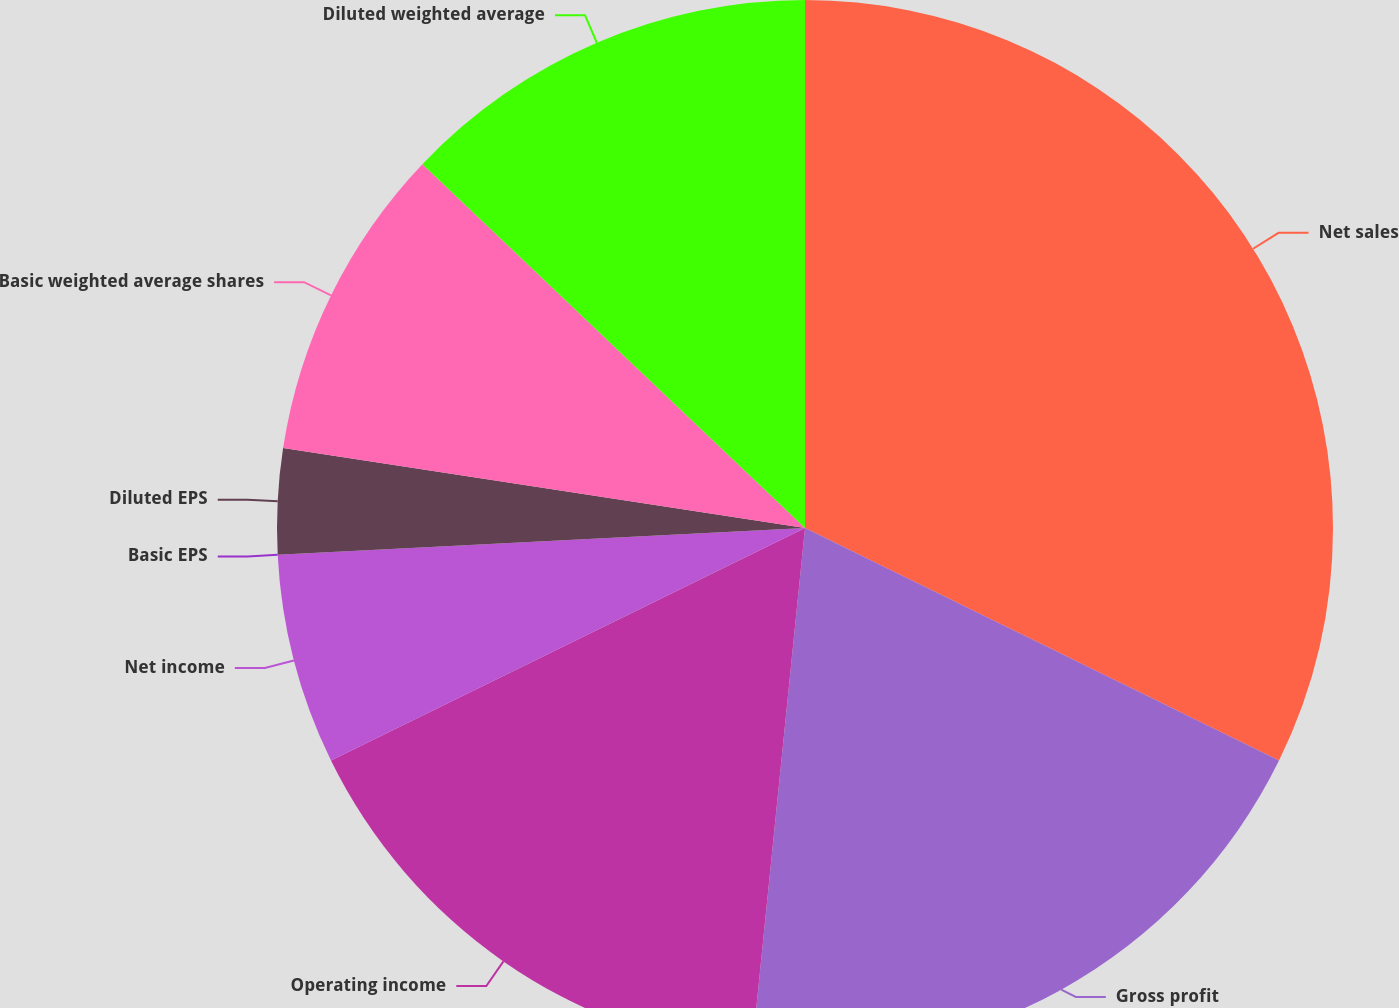Convert chart. <chart><loc_0><loc_0><loc_500><loc_500><pie_chart><fcel>Net sales<fcel>Gross profit<fcel>Operating income<fcel>Net income<fcel>Basic EPS<fcel>Diluted EPS<fcel>Basic weighted average shares<fcel>Diluted weighted average<nl><fcel>32.26%<fcel>19.35%<fcel>16.13%<fcel>6.45%<fcel>0.0%<fcel>3.23%<fcel>9.68%<fcel>12.9%<nl></chart> 